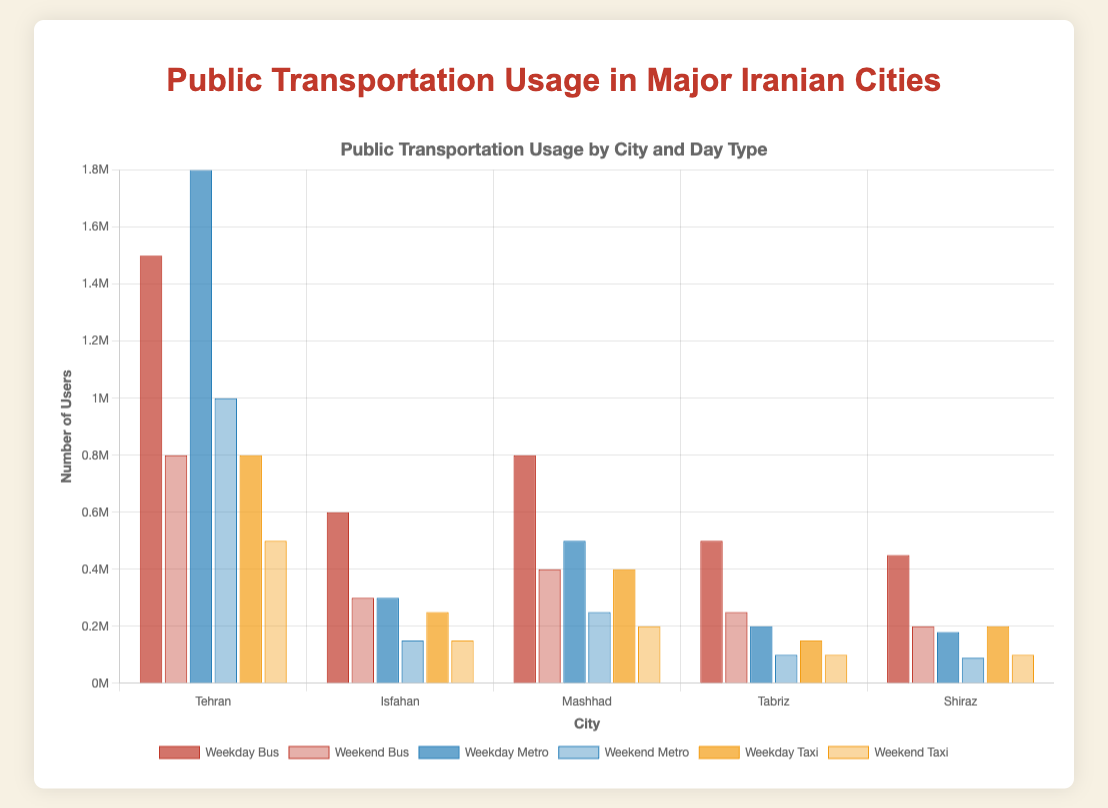What is the difference in weekday bus usage between Tehran and Isfahan? To find the difference, subtract the number of weekday bus users in Isfahan from the number of weekday bus users in Tehran: 1500000 - 600000 = 900000
Answer: 900000 Which city has the highest weekend metro usage? By comparing the weekend metro usage among cities, Tehran has the highest number with 1000000 users
Answer: Tehran What is the total taxi usage in Mashhad across both weekday and weekend? Sum the weekday and weekend taxi users in Mashhad: 400000 (weekday) + 200000 (weekend) = 600000
Answer: 600000 Between Tabriz and Shiraz, which city has a higher weekday metro usage? By comparing the weekday metro usage, Tabriz has 200000 users while Shiraz has 180000 users. Hence, Tabriz has higher usage.
Answer: Tabriz What is the average weekend bus usage across all cities? Sum the weekend bus usage across all cities: 800000 (Tehran) + 300000 (Isfahan) + 400000 (Mashhad) + 250000 (Tabriz) + 200000 (Shiraz) = 1950000. Then, divide by the number of cities (5): 1950000 / 5 = 390000
Answer: 390000 By how much does Tehran's weekday taxi usage exceed its weekend taxi usage? Subtract Tehran's weekend taxi usage from its weekday taxi usage: 800000 (weekday) - 500000 (weekend) = 300000
Answer: 300000 Which transportation mode in Isfahan has the lowest weekend usage? Comparing weekend usage for all modes in Isfahan, the metro has the lowest with 150000 users
Answer: Metro What is the combined weekday metro usage for Tehran and Mashhad? Sum the weekday metro usage for Tehran and Mashhad: 1800000 (Tehran) + 500000 (Mashhad) = 2300000
Answer: 2300000 How does the height of the weekend bus usage bar for Shiraz compare visually with the height of the weekday bus usage bar for the same city? The height of the weekend bus usage bar for Shiraz is approximately half the height of the weekday bus usage bar
Answer: Approximately half 